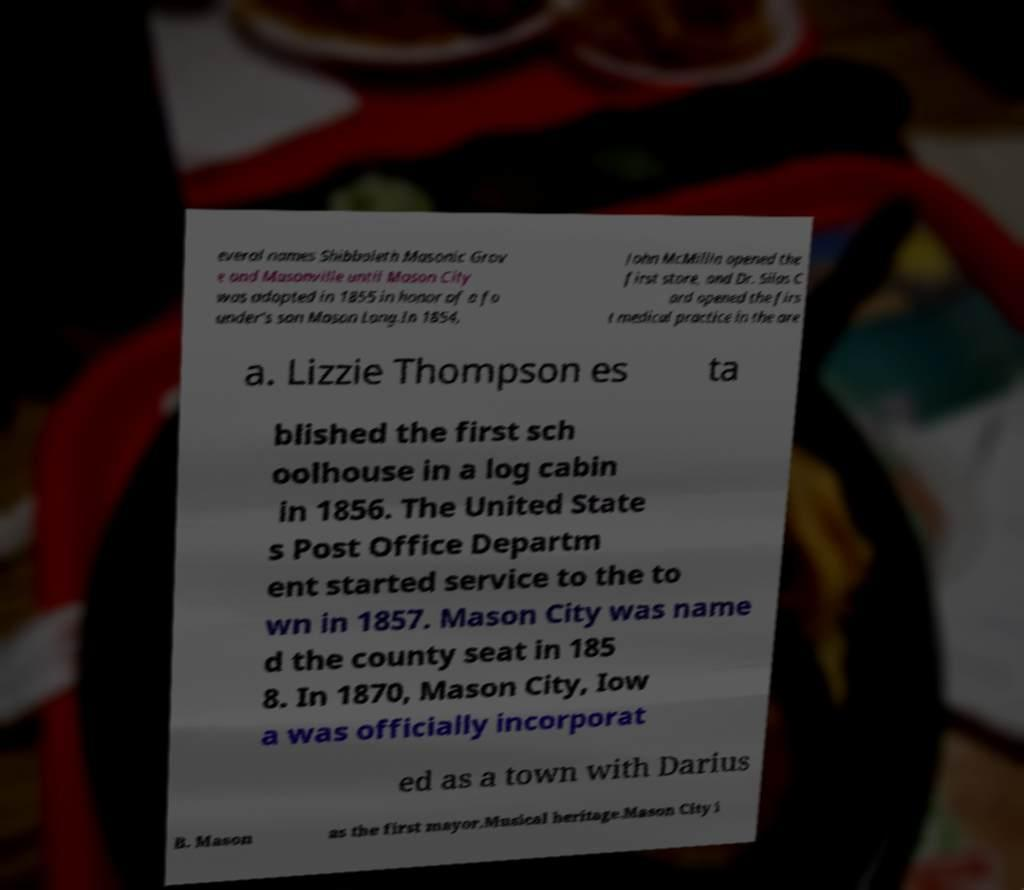There's text embedded in this image that I need extracted. Can you transcribe it verbatim? everal names Shibboleth Masonic Grov e and Masonville until Mason City was adopted in 1855 in honor of a fo under's son Mason Long.In 1854, John McMillin opened the first store, and Dr. Silas C ard opened the firs t medical practice in the are a. Lizzie Thompson es ta blished the first sch oolhouse in a log cabin in 1856. The United State s Post Office Departm ent started service to the to wn in 1857. Mason City was name d the county seat in 185 8. In 1870, Mason City, Iow a was officially incorporat ed as a town with Darius B. Mason as the first mayor.Musical heritage.Mason City i 